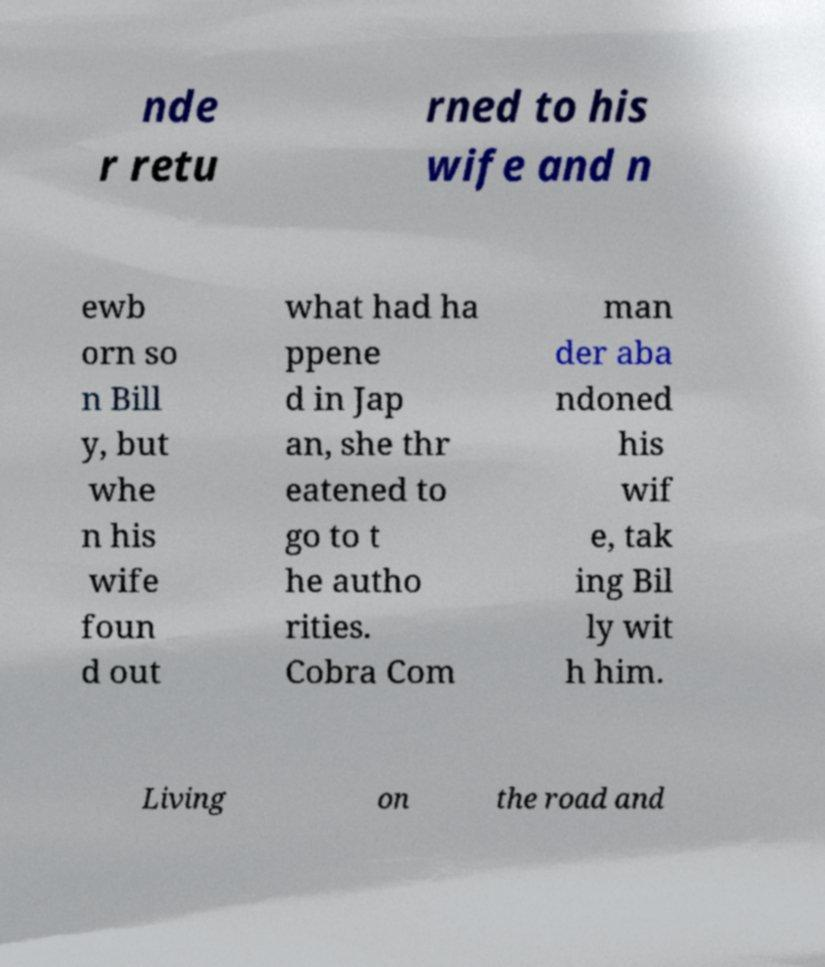Can you accurately transcribe the text from the provided image for me? nde r retu rned to his wife and n ewb orn so n Bill y, but whe n his wife foun d out what had ha ppene d in Jap an, she thr eatened to go to t he autho rities. Cobra Com man der aba ndoned his wif e, tak ing Bil ly wit h him. Living on the road and 